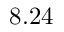Convert formula to latex. <formula><loc_0><loc_0><loc_500><loc_500>8 . 2 4</formula> 